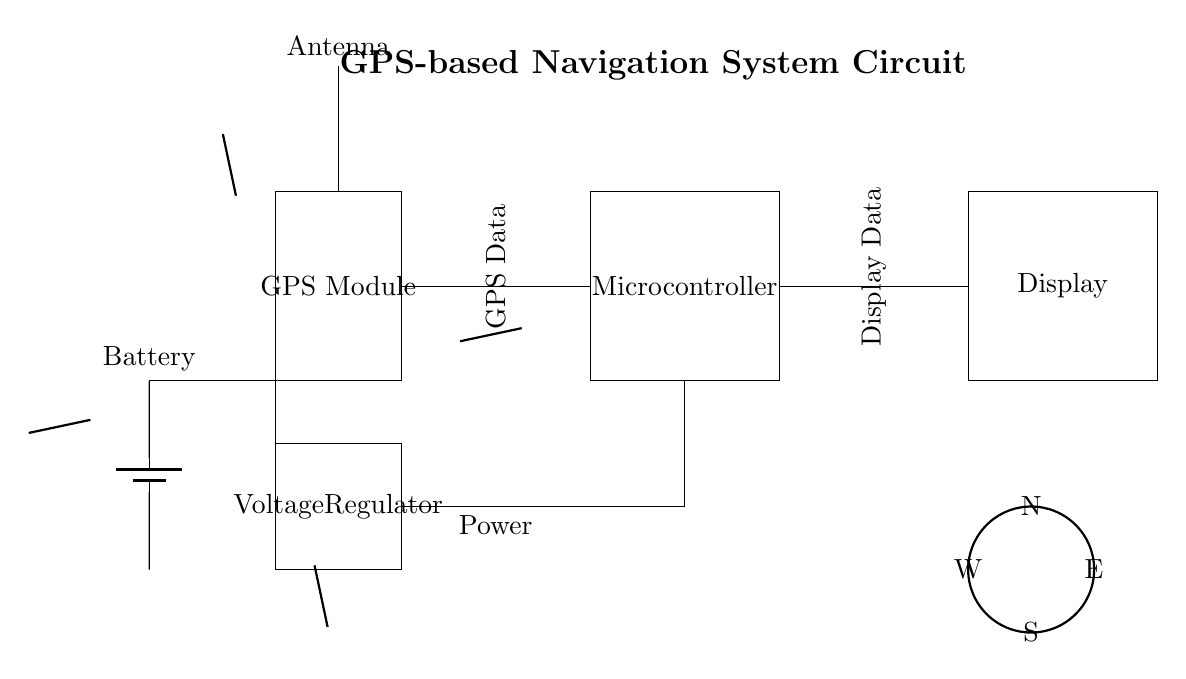What is the role of the GPS Module? The GPS Module is responsible for receiving GPS signals to determine location data. It processes the signals from satellites to output geographical coordinates.
Answer: Location tracking What component regulates the power supply? The Voltage Regulator ensures that the voltage supplied to the circuit's components is consistent and stable, converting varying input voltage to a fixed output voltage required by the circuit.
Answer: Voltage Regulator How many key components are there in this circuit? The circuit diagram consists of five key components: Battery, Voltage Regulator, GPS Module, Microcontroller, and Display. Each plays a distinct role in the navigation system's operation.
Answer: Five What connects the GPS Module to the Microcontroller? GPS Data connections link the GPS Module to the Microcontroller. This allows the Microcontroller to receive and process the location data sent out by the GPS Module.
Answer: GPS Data What is the purpose of the Display? The Display is used to present the processed location information to the user in a readable format, allowing users to view their current position or direction based on GPS data.
Answer: User interface Which direction does the antenna aim to receive signals? The antenna is oriented upward, as indicated by the upward arrow above it, optimizing its ability to receive GPS signals from satellites in the sky.
Answer: Upward 